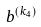Convert formula to latex. <formula><loc_0><loc_0><loc_500><loc_500>b ^ { ( k _ { 4 } ) }</formula> 